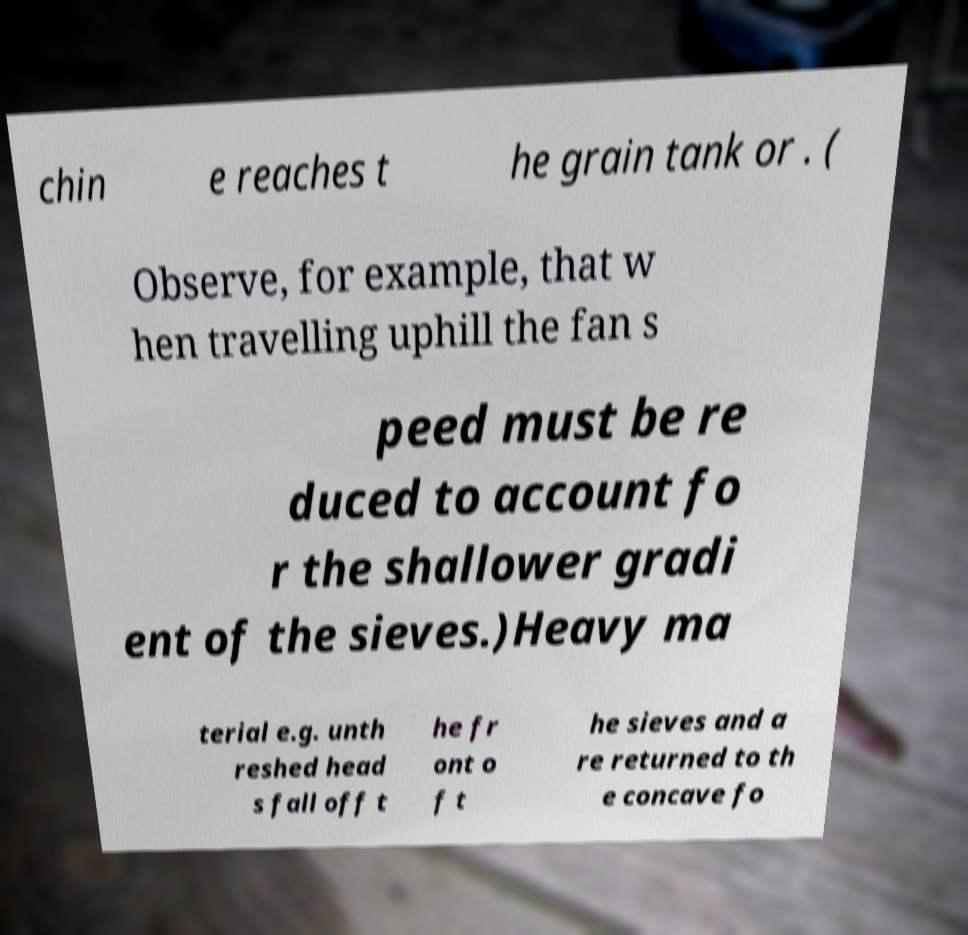Please read and relay the text visible in this image. What does it say? chin e reaches t he grain tank or . ( Observe, for example, that w hen travelling uphill the fan s peed must be re duced to account fo r the shallower gradi ent of the sieves.)Heavy ma terial e.g. unth reshed head s fall off t he fr ont o f t he sieves and a re returned to th e concave fo 